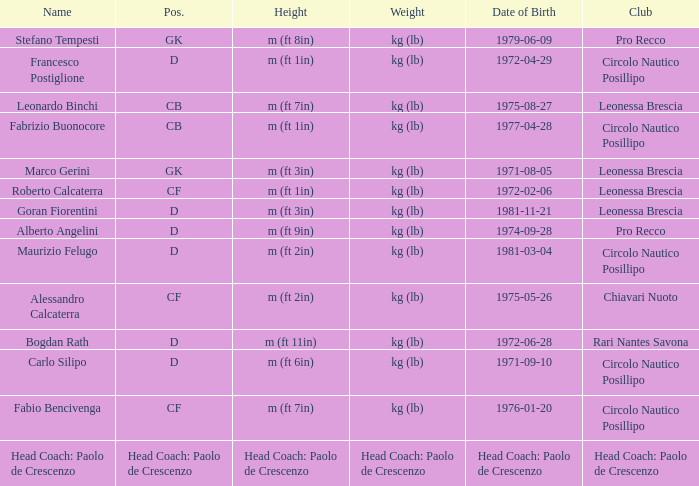Could you parse the entire table? {'header': ['Name', 'Pos.', 'Height', 'Weight', 'Date of Birth', 'Club'], 'rows': [['Stefano Tempesti', 'GK', 'm (ft 8in)', 'kg (lb)', '1979-06-09', 'Pro Recco'], ['Francesco Postiglione', 'D', 'm (ft 1in)', 'kg (lb)', '1972-04-29', 'Circolo Nautico Posillipo'], ['Leonardo Binchi', 'CB', 'm (ft 7in)', 'kg (lb)', '1975-08-27', 'Leonessa Brescia'], ['Fabrizio Buonocore', 'CB', 'm (ft 1in)', 'kg (lb)', '1977-04-28', 'Circolo Nautico Posillipo'], ['Marco Gerini', 'GK', 'm (ft 3in)', 'kg (lb)', '1971-08-05', 'Leonessa Brescia'], ['Roberto Calcaterra', 'CF', 'm (ft 1in)', 'kg (lb)', '1972-02-06', 'Leonessa Brescia'], ['Goran Fiorentini', 'D', 'm (ft 3in)', 'kg (lb)', '1981-11-21', 'Leonessa Brescia'], ['Alberto Angelini', 'D', 'm (ft 9in)', 'kg (lb)', '1974-09-28', 'Pro Recco'], ['Maurizio Felugo', 'D', 'm (ft 2in)', 'kg (lb)', '1981-03-04', 'Circolo Nautico Posillipo'], ['Alessandro Calcaterra', 'CF', 'm (ft 2in)', 'kg (lb)', '1975-05-26', 'Chiavari Nuoto'], ['Bogdan Rath', 'D', 'm (ft 11in)', 'kg (lb)', '1972-06-28', 'Rari Nantes Savona'], ['Carlo Silipo', 'D', 'm (ft 6in)', 'kg (lb)', '1971-09-10', 'Circolo Nautico Posillipo'], ['Fabio Bencivenga', 'CF', 'm (ft 7in)', 'kg (lb)', '1976-01-20', 'Circolo Nautico Posillipo'], ['Head Coach: Paolo de Crescenzo', 'Head Coach: Paolo de Crescenzo', 'Head Coach: Paolo de Crescenzo', 'Head Coach: Paolo de Crescenzo', 'Head Coach: Paolo de Crescenzo', 'Head Coach: Paolo de Crescenzo']]} What is the heaviness of the item with a birthdate of 1981-11-21? Kg (lb). 